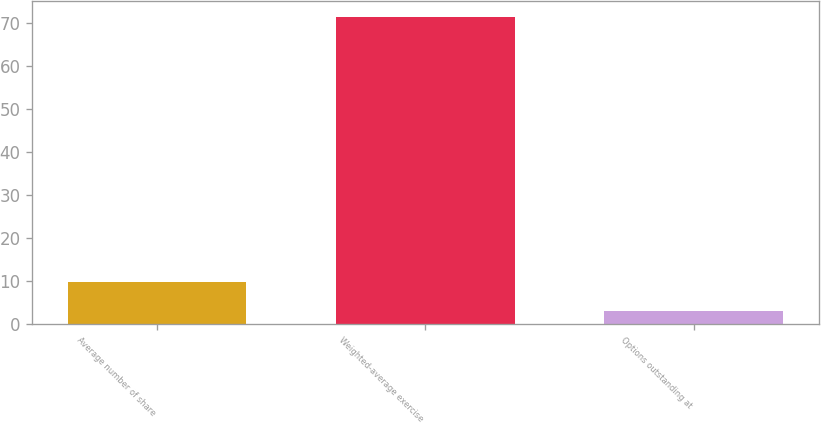<chart> <loc_0><loc_0><loc_500><loc_500><bar_chart><fcel>Average number of share<fcel>Weighted-average exercise<fcel>Options outstanding at<nl><fcel>9.85<fcel>71.49<fcel>3<nl></chart> 